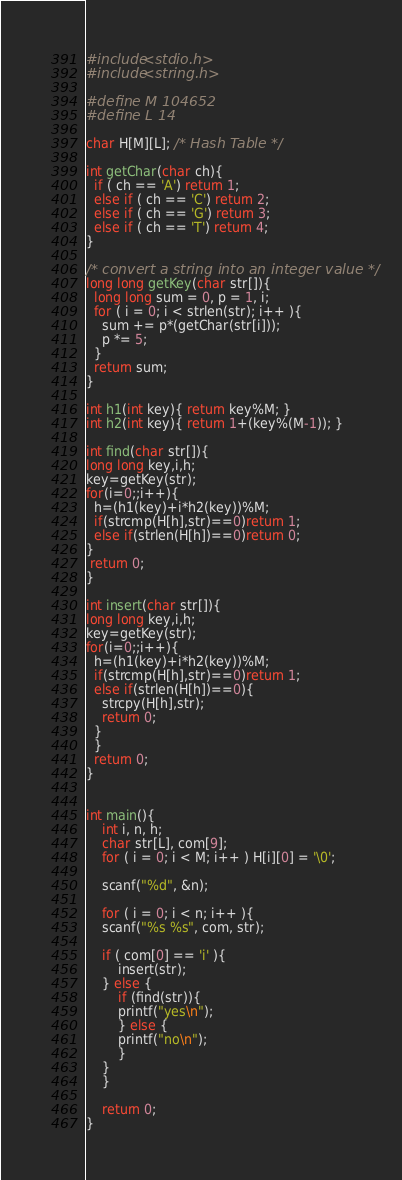<code> <loc_0><loc_0><loc_500><loc_500><_C_>#include<stdio.h>
#include<string.h>

#define M 104652
#define L 14

char H[M][L]; /* Hash Table */

int getChar(char ch){
  if ( ch == 'A') return 1;
  else if ( ch == 'C') return 2;
  else if ( ch == 'G') return 3;
  else if ( ch == 'T') return 4;
}

/* convert a string into an integer value */
long long getKey(char str[]){
  long long sum = 0, p = 1, i;
  for ( i = 0; i < strlen(str); i++ ){
    sum += p*(getChar(str[i]));
    p *= 5;
  }
  return sum;
}

int h1(int key){ return key%M; }
int h2(int key){ return 1+(key%(M-1)); }

int find(char str[]){
long long key,i,h;
key=getKey(str);
for(i=0;;i++){
  h=(h1(key)+i*h2(key))%M;
  if(strcmp(H[h],str)==0)return 1;
  else if(strlen(H[h])==0)return 0;
}
 return 0;
}

int insert(char str[]){
long long key,i,h;
key=getKey(str);
for(i=0;;i++){
  h=(h1(key)+i*h2(key))%M;
  if(strcmp(H[h],str)==0)return 1;
  else if(strlen(H[h])==0){
    strcpy(H[h],str);
    return 0;
  }
  }
  return 0;
}
    

int main(){
    int i, n, h;
    char str[L], com[9];
    for ( i = 0; i < M; i++ ) H[i][0] = '\0';
    
    scanf("%d", &n);
    
    for ( i = 0; i < n; i++ ){
	scanf("%s %s", com, str);
	
	if ( com[0] == 'i' ){
	    insert(str);
	} else {
	    if (find(str)){
		printf("yes\n");
	    } else {
		printf("no\n");
	    }
	}
    }

    return 0;
}</code> 